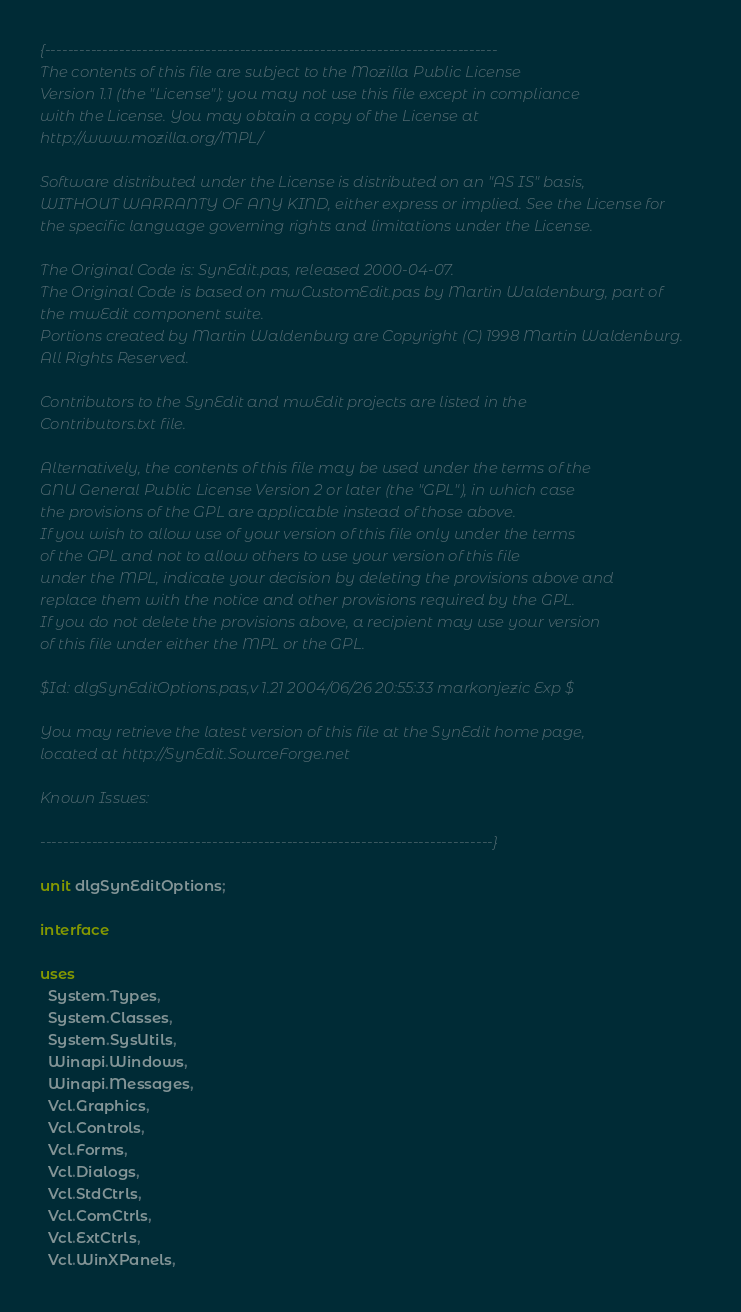Convert code to text. <code><loc_0><loc_0><loc_500><loc_500><_Pascal_>{-------------------------------------------------------------------------------
The contents of this file are subject to the Mozilla Public License
Version 1.1 (the "License"); you may not use this file except in compliance
with the License. You may obtain a copy of the License at
http://www.mozilla.org/MPL/

Software distributed under the License is distributed on an "AS IS" basis,
WITHOUT WARRANTY OF ANY KIND, either express or implied. See the License for
the specific language governing rights and limitations under the License.

The Original Code is: SynEdit.pas, released 2000-04-07.
The Original Code is based on mwCustomEdit.pas by Martin Waldenburg, part of
the mwEdit component suite.
Portions created by Martin Waldenburg are Copyright (C) 1998 Martin Waldenburg.
All Rights Reserved.

Contributors to the SynEdit and mwEdit projects are listed in the
Contributors.txt file.

Alternatively, the contents of this file may be used under the terms of the
GNU General Public License Version 2 or later (the "GPL"), in which case
the provisions of the GPL are applicable instead of those above.
If you wish to allow use of your version of this file only under the terms
of the GPL and not to allow others to use your version of this file
under the MPL, indicate your decision by deleting the provisions above and
replace them with the notice and other provisions required by the GPL.
If you do not delete the provisions above, a recipient may use your version
of this file under either the MPL or the GPL.

$Id: dlgSynEditOptions.pas,v 1.21 2004/06/26 20:55:33 markonjezic Exp $

You may retrieve the latest version of this file at the SynEdit home page,
located at http://SynEdit.SourceForge.net

Known Issues:

-------------------------------------------------------------------------------}

unit dlgSynEditOptions;

interface

uses
  System.Types,
  System.Classes,
  System.SysUtils,
  Winapi.Windows,
  Winapi.Messages,
  Vcl.Graphics,
  Vcl.Controls,
  Vcl.Forms,
  Vcl.Dialogs,
  Vcl.StdCtrls,
  Vcl.ComCtrls,
  Vcl.ExtCtrls,
  Vcl.WinXPanels,</code> 